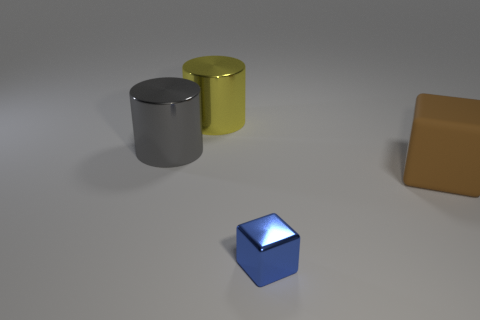What number of large things are both in front of the yellow shiny cylinder and behind the brown rubber block?
Ensure brevity in your answer.  1. Is the small object made of the same material as the gray thing that is in front of the large yellow metal object?
Offer a terse response. Yes. How many yellow things are either big shiny cubes or big cylinders?
Keep it short and to the point. 1. Are there any purple rubber balls of the same size as the blue metallic thing?
Provide a short and direct response. No. The cube that is on the left side of the object that is right of the object in front of the big rubber cube is made of what material?
Provide a short and direct response. Metal. Are there the same number of gray things right of the big block and large cyan objects?
Provide a short and direct response. Yes. Are the block in front of the big brown object and the cylinder behind the big gray cylinder made of the same material?
Give a very brief answer. Yes. How many objects are either gray metallic cylinders or things that are on the left side of the rubber block?
Provide a short and direct response. 3. Are there any yellow metallic things of the same shape as the large brown thing?
Provide a succinct answer. No. There is a metallic thing in front of the cube behind the metal block in front of the gray thing; how big is it?
Your response must be concise. Small. 